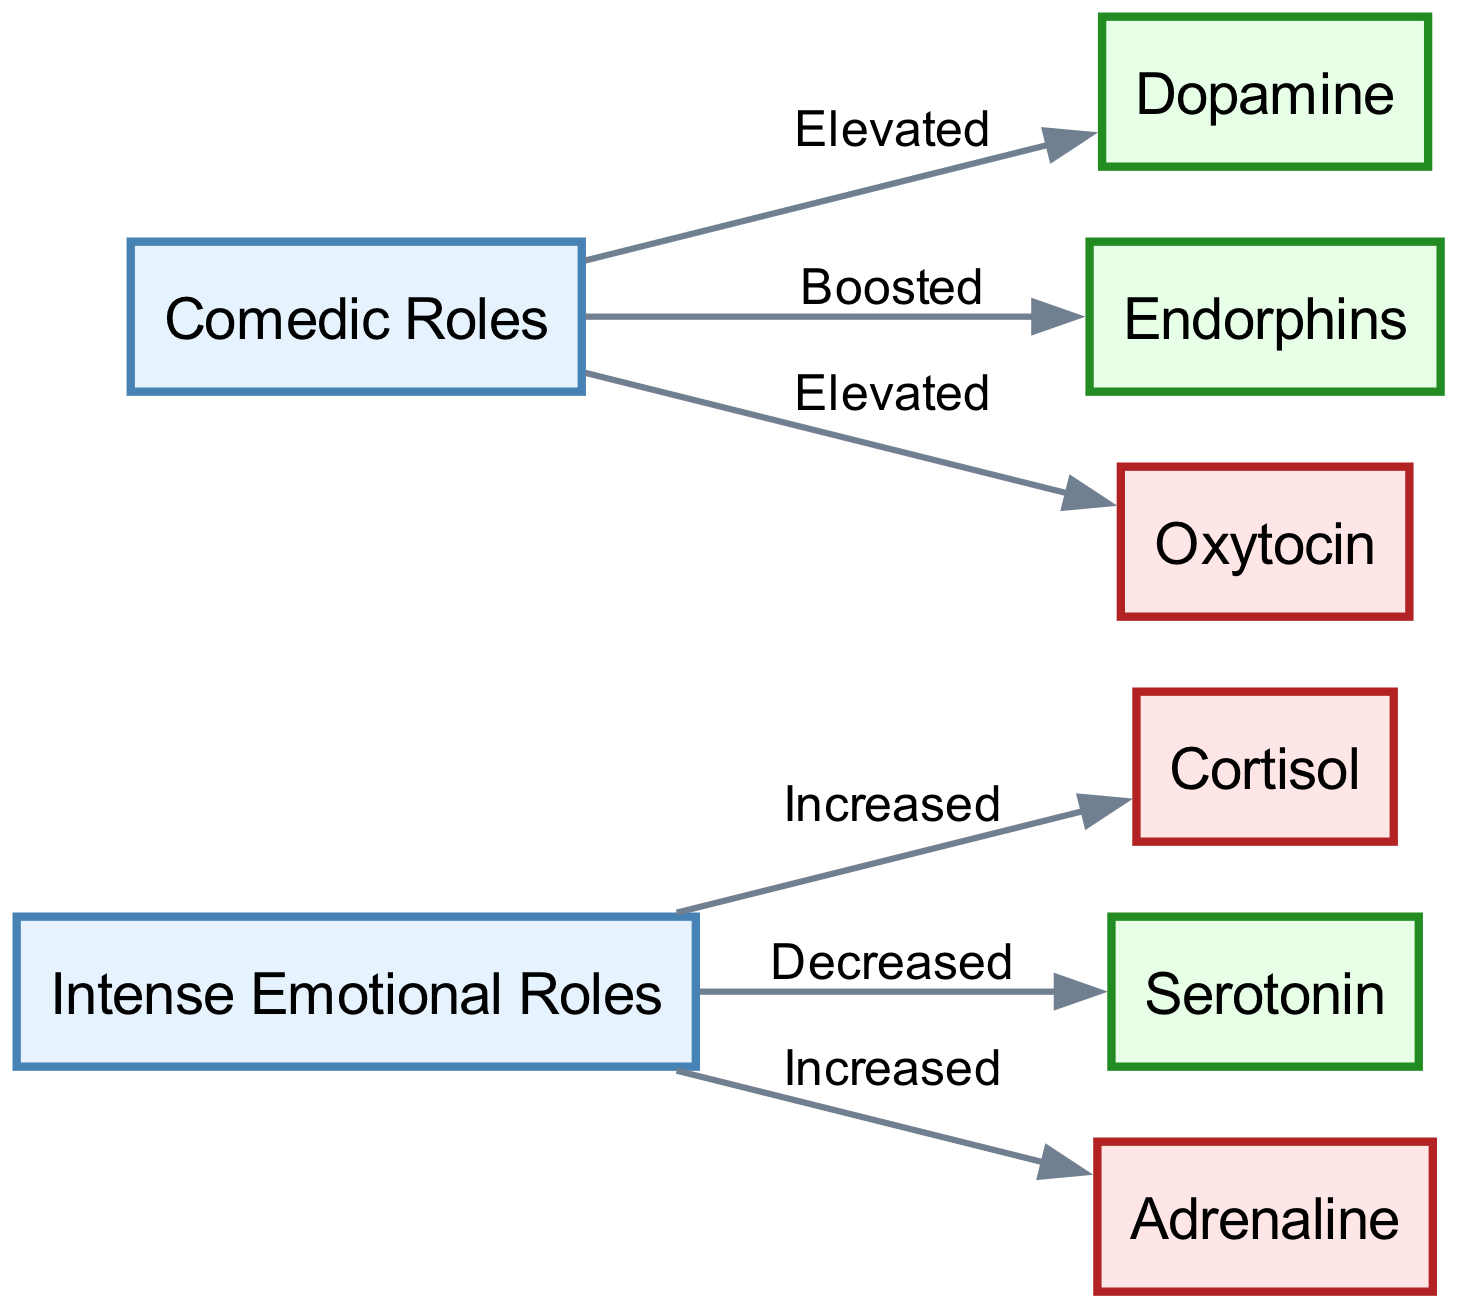What are the two types of roles depicted in the diagram? The diagram features two main categories highlighted as "Intense Emotional Roles" and "Comedic Roles".
Answer: Intense Emotional Roles, Comedic Roles Which hormone is increased in actors performing intense emotional roles? The diagram indicates that cortisol is the hormone associated with an increase in actors engaged in intense emotional roles.
Answer: Cortisol How many neurochemicals are boosted or elevated in comedic roles? The diagram lists two neurochemicals related to comedic roles, specifically dopamine and endorphins (endorphins also mentioned as boosted).
Answer: Two What happens to serotonin levels in actors undertaking intense emotional roles? The relationship stated in the diagram shows that serotonin levels are decreased when actors take on intense emotional roles.
Answer: Decreased Which neurochemical is associated with a boost in comedic roles? The diagram clearly associates endorphins with a boost experienced by actors performing in comedic roles.
Answer: Endorphins Explain the relationship between intense emotional roles and adrenaline. According to the diagram, there is a direct relationship showing that adrenaline is increased when actors are involved in intense emotional roles. This indicates heightened physiological arousal.
Answer: Increased What hormone is elevated for actors in comedic roles? The diagram identifies oxytocin as a hormone that is elevated in actors who perform comedic roles.
Answer: Oxytocin Which hormone's levels are increased for both types of roles? The diagram shows that cortisol is increased for intense emotional roles, but there are no overlaps, suggesting the levels are unique to that role type, while adrenaline does not apply to comedic roles. Hence, no hormone is shared for both role types.
Answer: None 